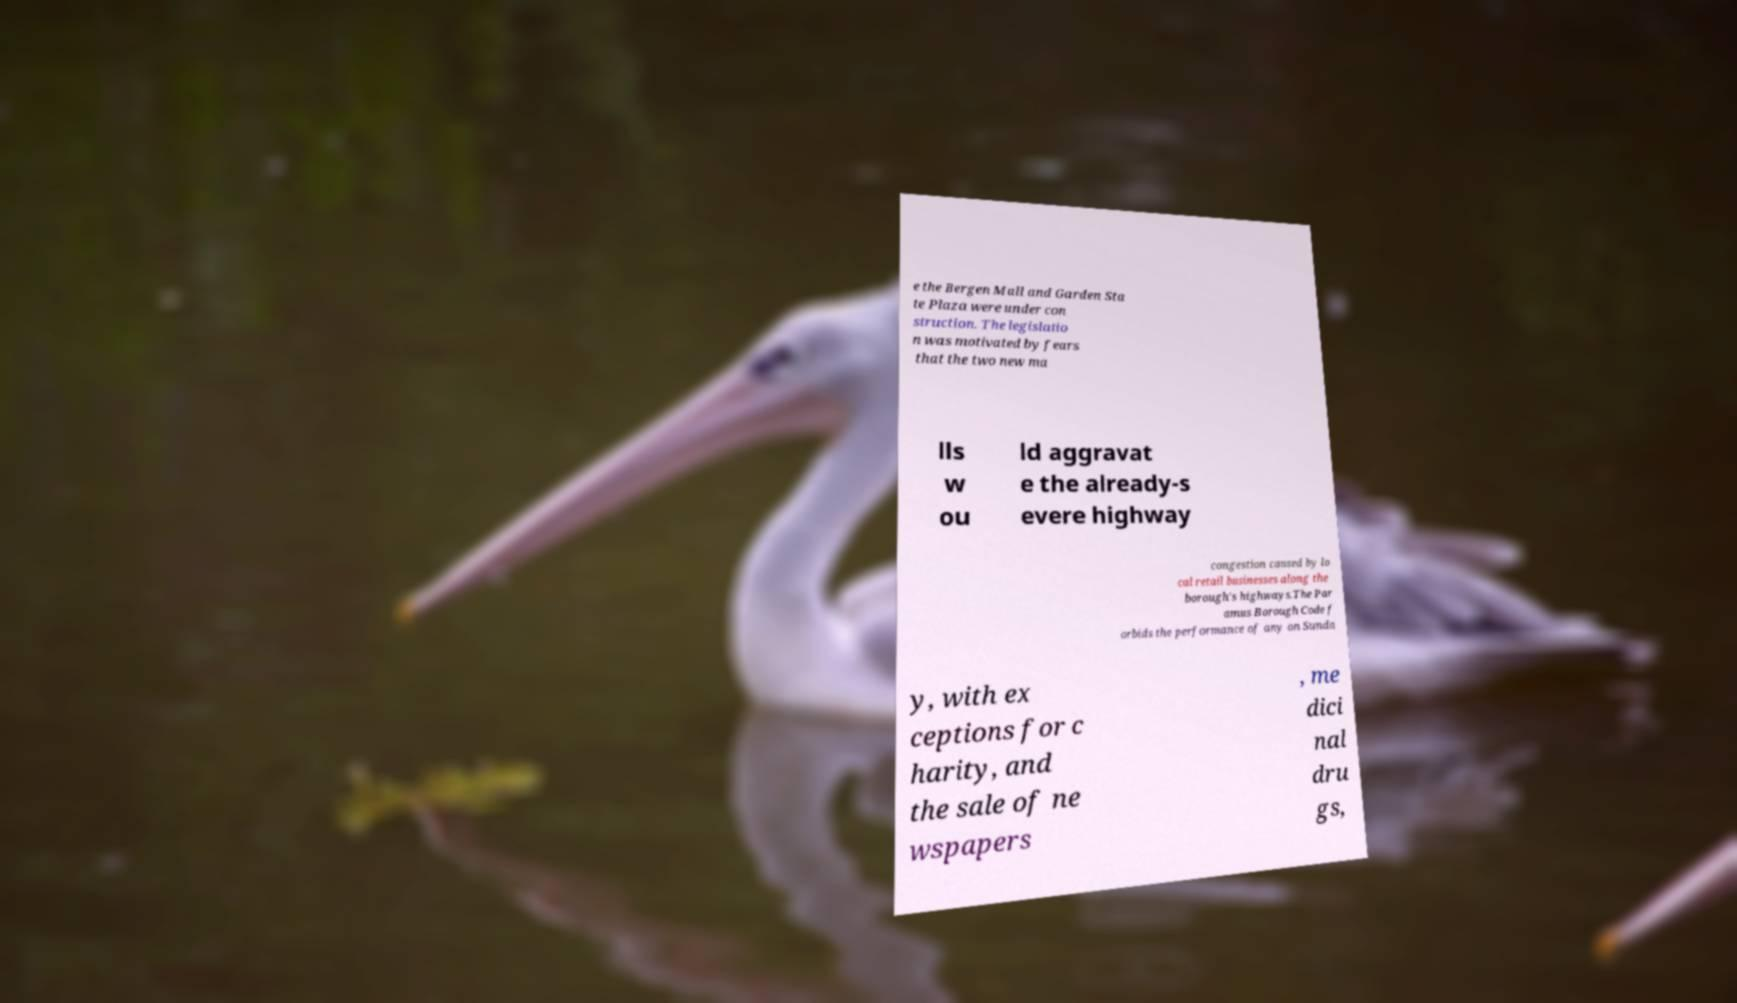What messages or text are displayed in this image? I need them in a readable, typed format. e the Bergen Mall and Garden Sta te Plaza were under con struction. The legislatio n was motivated by fears that the two new ma lls w ou ld aggravat e the already-s evere highway congestion caused by lo cal retail businesses along the borough's highways.The Par amus Borough Code f orbids the performance of any on Sunda y, with ex ceptions for c harity, and the sale of ne wspapers , me dici nal dru gs, 